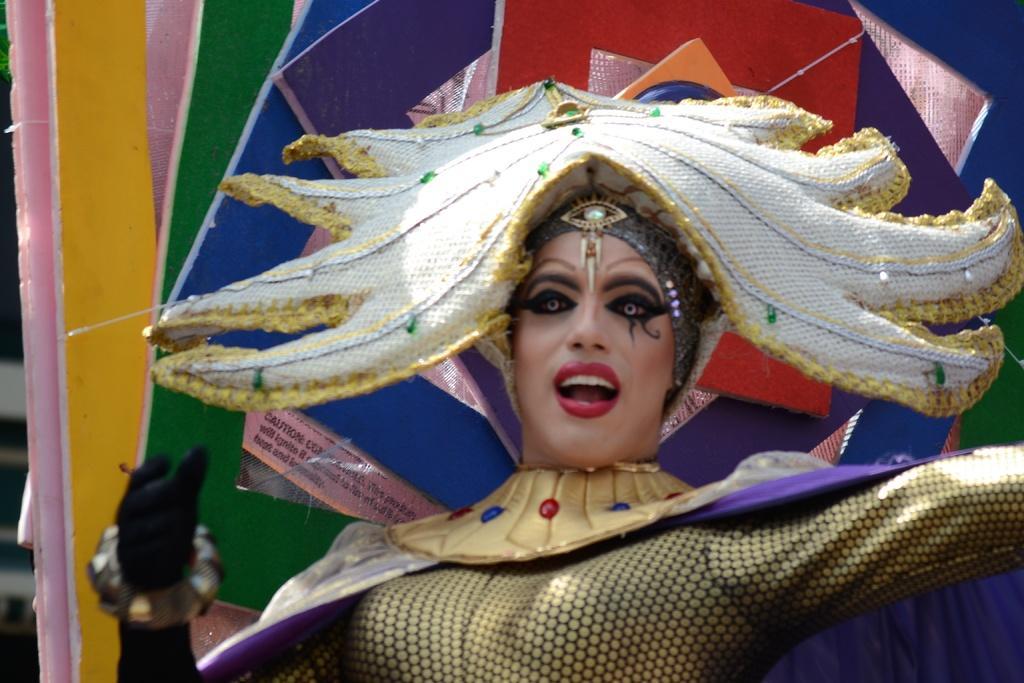How would you summarize this image in a sentence or two? In this image is we can see a woman is standing, she is wearing a costume, the background is colorful. 